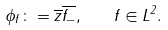<formula> <loc_0><loc_0><loc_500><loc_500>\phi _ { f } \colon = \overline { z } \overline { f _ { - } } , \quad f \in L ^ { 2 } .</formula> 